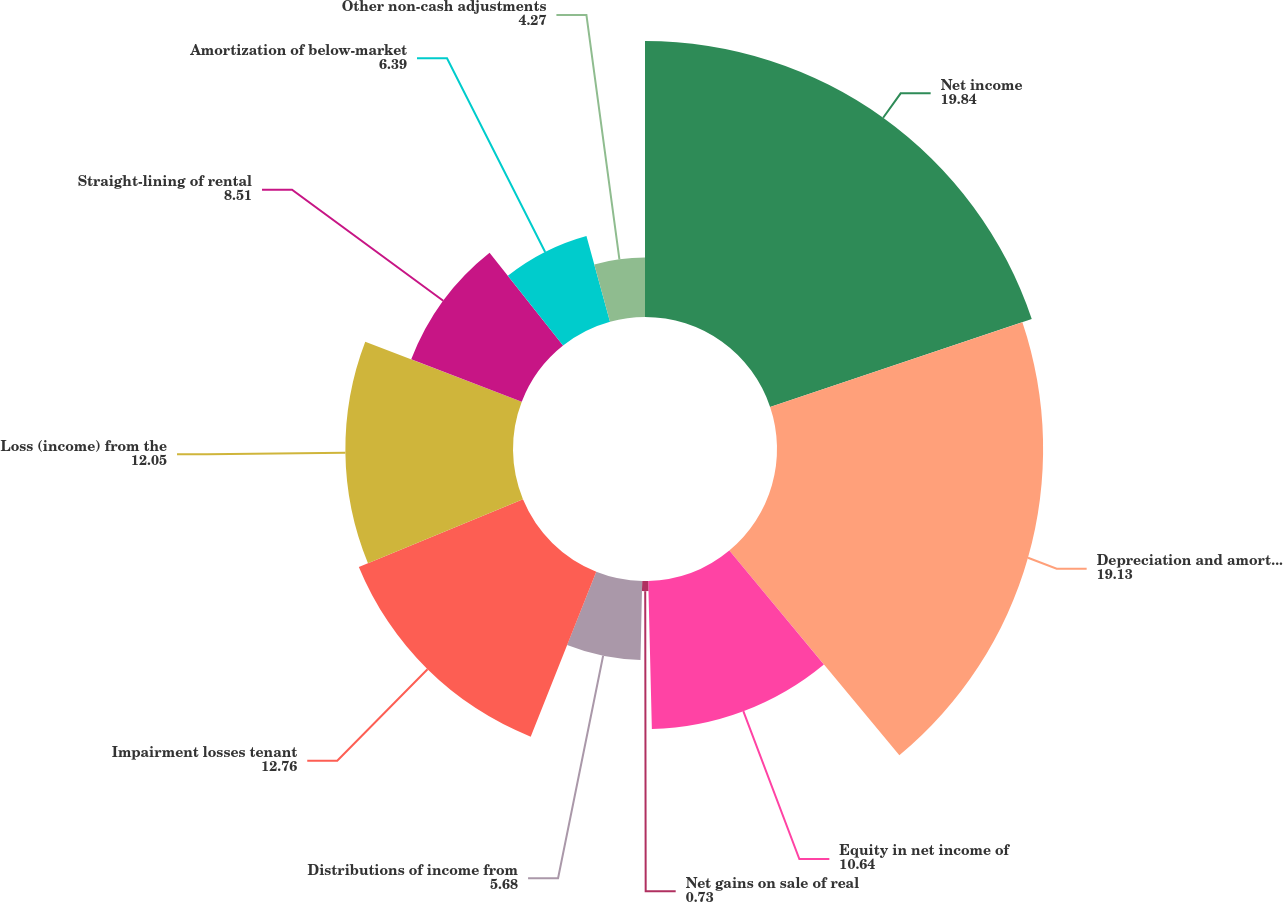Convert chart. <chart><loc_0><loc_0><loc_500><loc_500><pie_chart><fcel>Net income<fcel>Depreciation and amortization<fcel>Equity in net income of<fcel>Net gains on sale of real<fcel>Distributions of income from<fcel>Impairment losses tenant<fcel>Loss (income) from the<fcel>Straight-lining of rental<fcel>Amortization of below-market<fcel>Other non-cash adjustments<nl><fcel>19.84%<fcel>19.13%<fcel>10.64%<fcel>0.73%<fcel>5.68%<fcel>12.76%<fcel>12.05%<fcel>8.51%<fcel>6.39%<fcel>4.27%<nl></chart> 